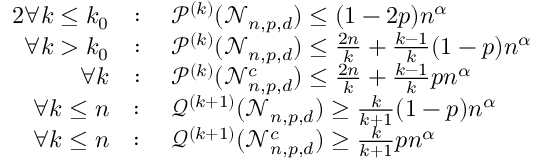Convert formula to latex. <formula><loc_0><loc_0><loc_500><loc_500>\begin{array} { r l } { { 2 } \forall k \leq k _ { 0 } } & { \colon \quad \mathcal { P } ^ { ( k ) } ( \mathcal { N } _ { n , p , d } ) \leq ( 1 - 2 p ) n ^ { \alpha } } \\ { \forall k > k _ { 0 } } & { \colon \quad \mathcal { P } ^ { ( k ) } ( \mathcal { N } _ { n , p , d } ) \leq \frac { 2 n } { k } + \frac { k - 1 } { k } ( 1 - p ) n ^ { \alpha } } \\ { \forall k } & { \colon \quad \mathcal { P } ^ { ( k ) } ( \mathcal { N } _ { n , p , d } ^ { c } ) \leq \frac { 2 n } { k } + \frac { k - 1 } { k } p n ^ { \alpha } } \\ { \forall k \leq n } & { \colon \quad \mathcal { Q } ^ { ( k + 1 ) } ( \mathcal { N } _ { n , p , d } ) \geq \frac { k } { k + 1 } ( 1 - p ) n ^ { \alpha } } \\ { \forall k \leq n } & { \colon \quad \mathcal { Q } ^ { ( k + 1 ) } ( \mathcal { N } _ { n , p , d } ^ { c } ) \geq \frac { k } { k + 1 } p n ^ { \alpha } } \end{array}</formula> 